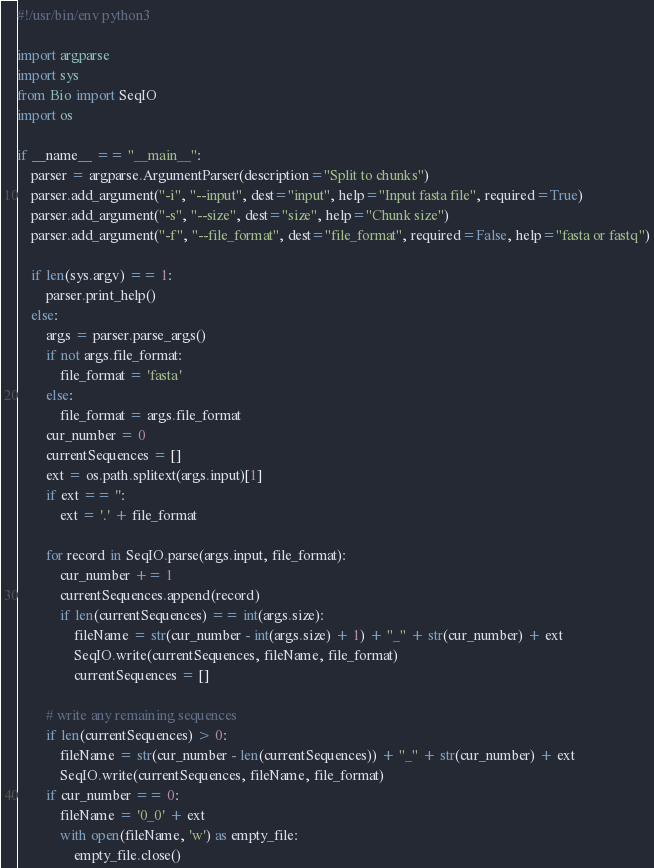Convert code to text. <code><loc_0><loc_0><loc_500><loc_500><_Python_>#!/usr/bin/env python3

import argparse
import sys
from Bio import SeqIO
import os

if __name__ == "__main__":
    parser = argparse.ArgumentParser(description="Split to chunks")
    parser.add_argument("-i", "--input", dest="input", help="Input fasta file", required=True)
    parser.add_argument("-s", "--size", dest="size", help="Chunk size")
    parser.add_argument("-f", "--file_format", dest="file_format", required=False, help="fasta or fastq")

    if len(sys.argv) == 1:
        parser.print_help()
    else:
        args = parser.parse_args()
        if not args.file_format:
            file_format = 'fasta'
        else:
            file_format = args.file_format
        cur_number = 0
        currentSequences = []
        ext = os.path.splitext(args.input)[1]
        if ext == '':
            ext = '.' + file_format

        for record in SeqIO.parse(args.input, file_format):
            cur_number += 1
            currentSequences.append(record)
            if len(currentSequences) == int(args.size):
                fileName = str(cur_number - int(args.size) + 1) + "_" + str(cur_number) + ext
                SeqIO.write(currentSequences, fileName, file_format)
                currentSequences = []

        # write any remaining sequences
        if len(currentSequences) > 0:
            fileName = str(cur_number - len(currentSequences)) + "_" + str(cur_number) + ext
            SeqIO.write(currentSequences, fileName, file_format)
        if cur_number == 0:
            fileName = '0_0' + ext
            with open(fileName, 'w') as empty_file:
                empty_file.close()</code> 